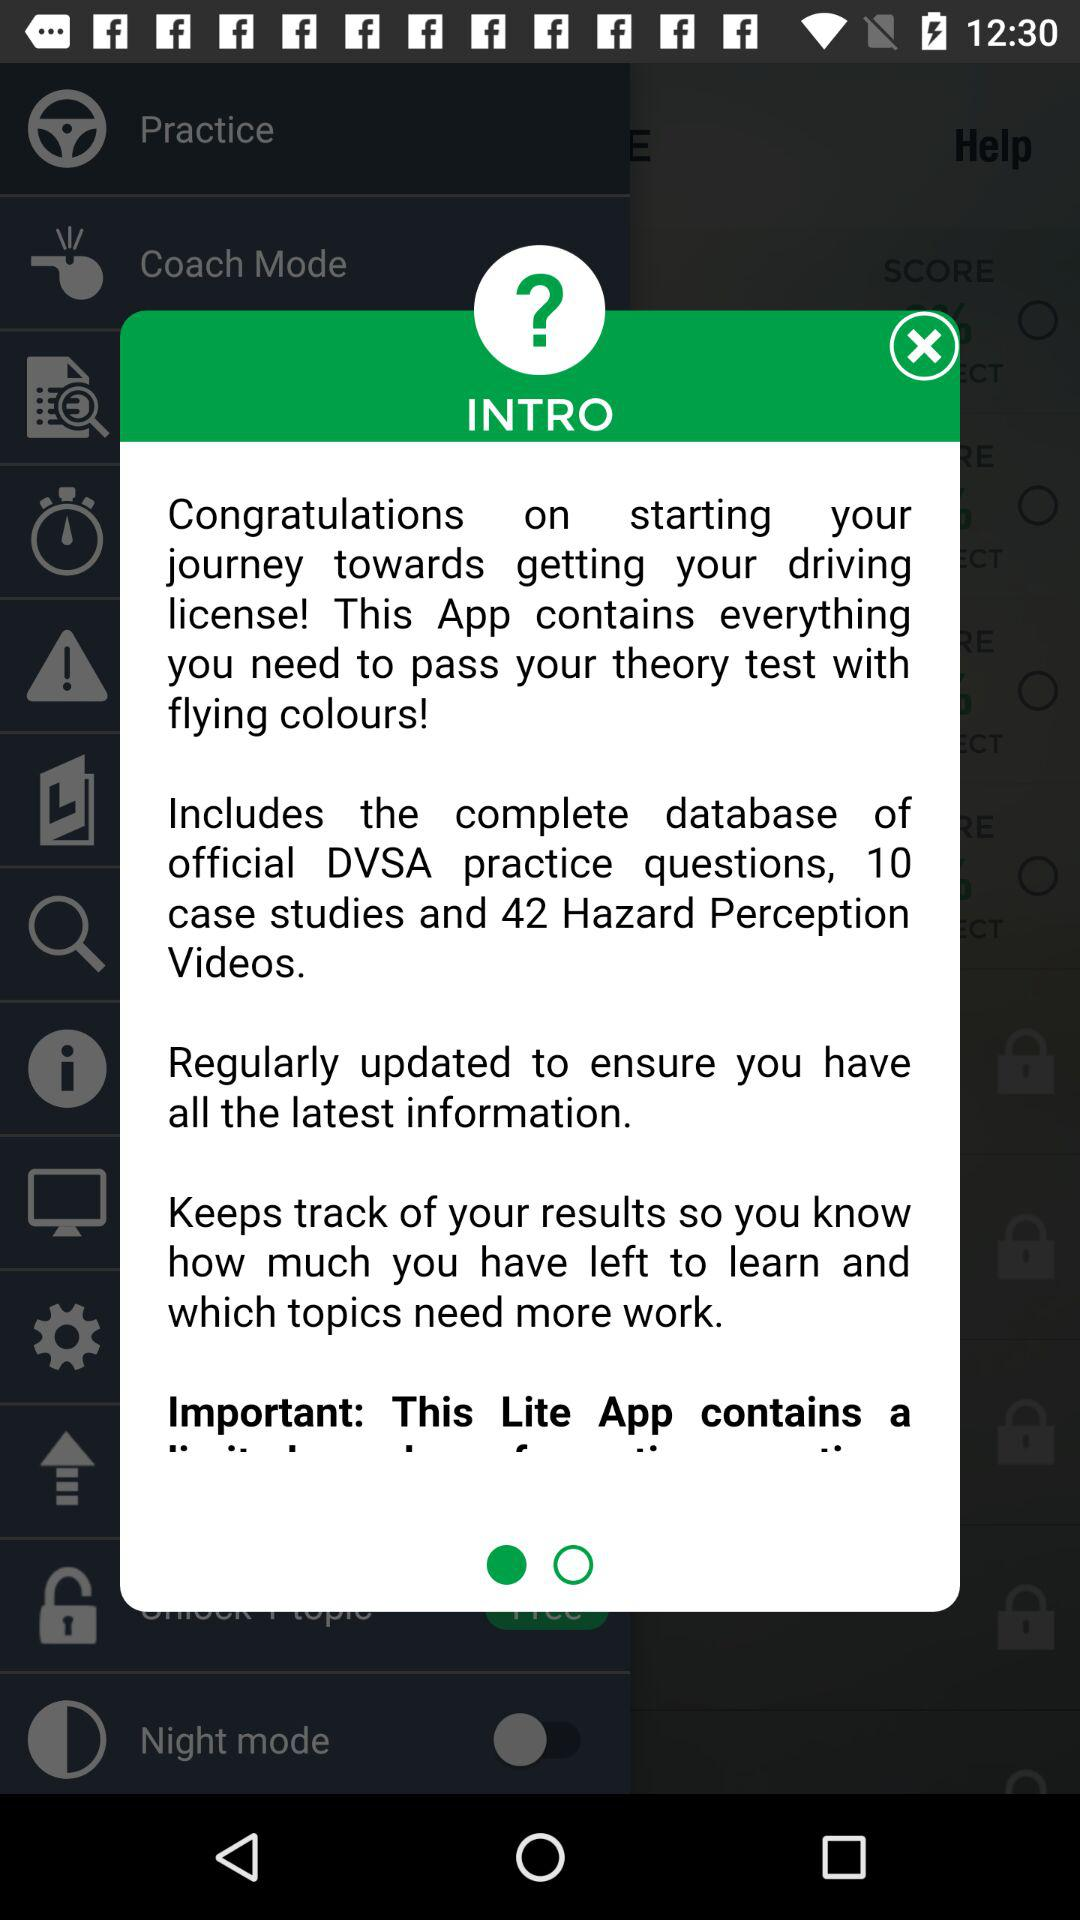How many videos are there in this app?
Answer the question using a single word or phrase. 42 